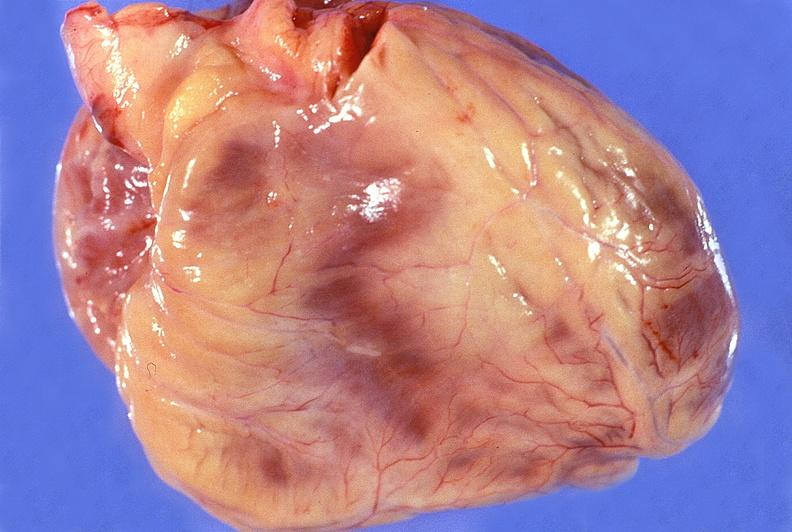does this image show normal cardiovascular?
Answer the question using a single word or phrase. Yes 